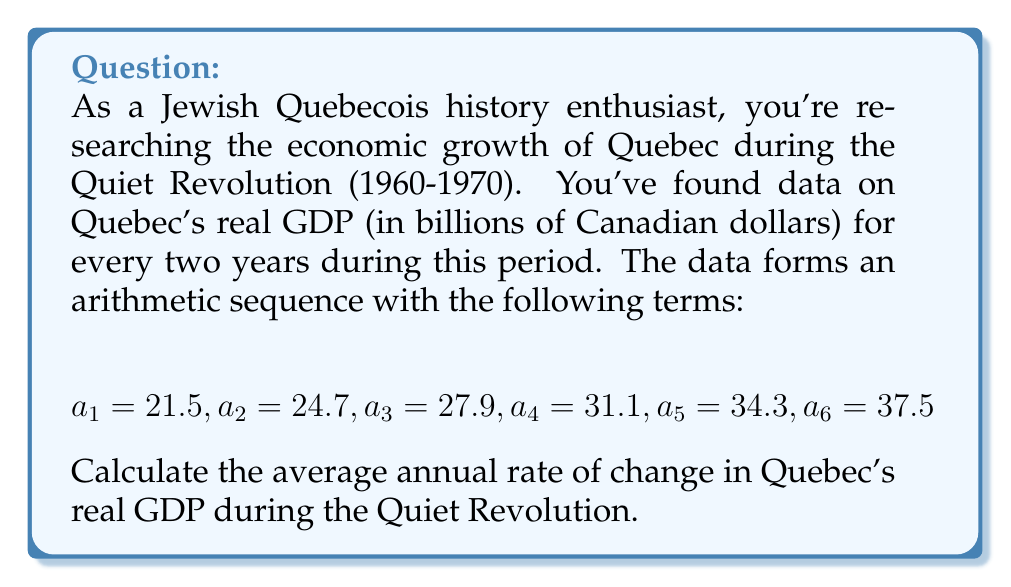Help me with this question. Let's approach this step-by-step:

1) First, we need to find the common difference (d) of the arithmetic sequence. We can do this by subtracting any term from the subsequent term:

   $$d = a_2 - a_1 = 24.7 - 21.5 = 3.2$$

2) This difference represents the change over two years. To get the annual change, we divide by 2:

   $$\text{Annual change} = \frac{3.2}{2} = 1.6 \text{ billion CAD}$$

3) Now, we need to calculate the average GDP over the period to express this as a percentage. We can use the formula for the average of an arithmetic sequence:

   $$\text{Average} = \frac{a_1 + a_n}{2} = \frac{21.5 + 37.5}{2} = 29.5 \text{ billion CAD}$$

4) To calculate the rate of change, we divide the annual change by the average GDP:

   $$\text{Rate of change} = \frac{\text{Annual change}}{\text{Average GDP}} \times 100\%$$
   
   $$= \frac{1.6}{29.5} \times 100\% \approx 5.42\%$$

Therefore, the average annual rate of change in Quebec's real GDP during the Quiet Revolution was approximately 5.42%.
Answer: 5.42% 